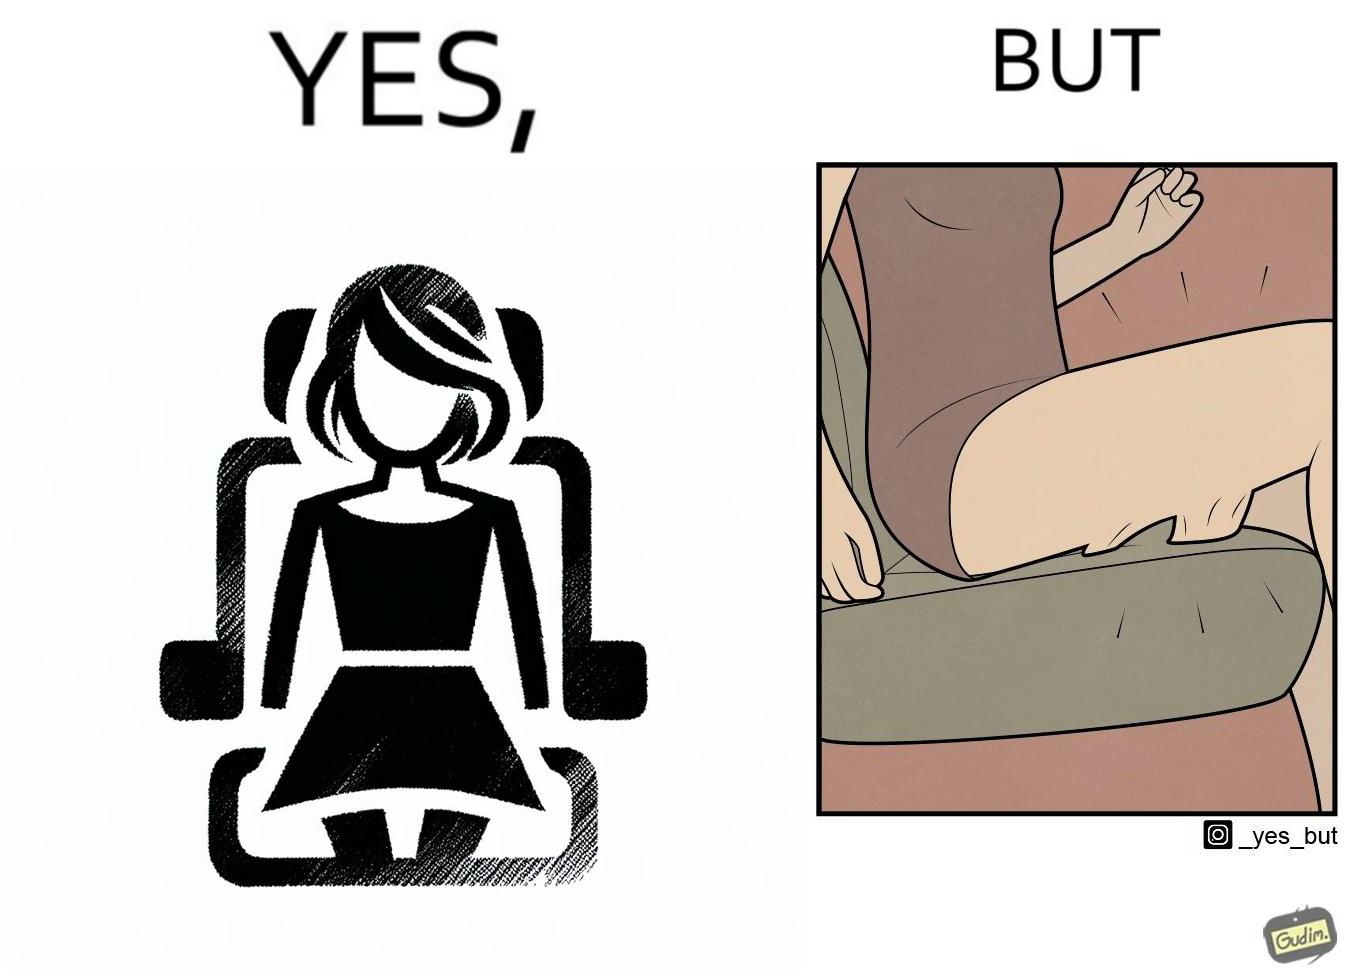Would you classify this image as satirical? Yes, this image is satirical. 